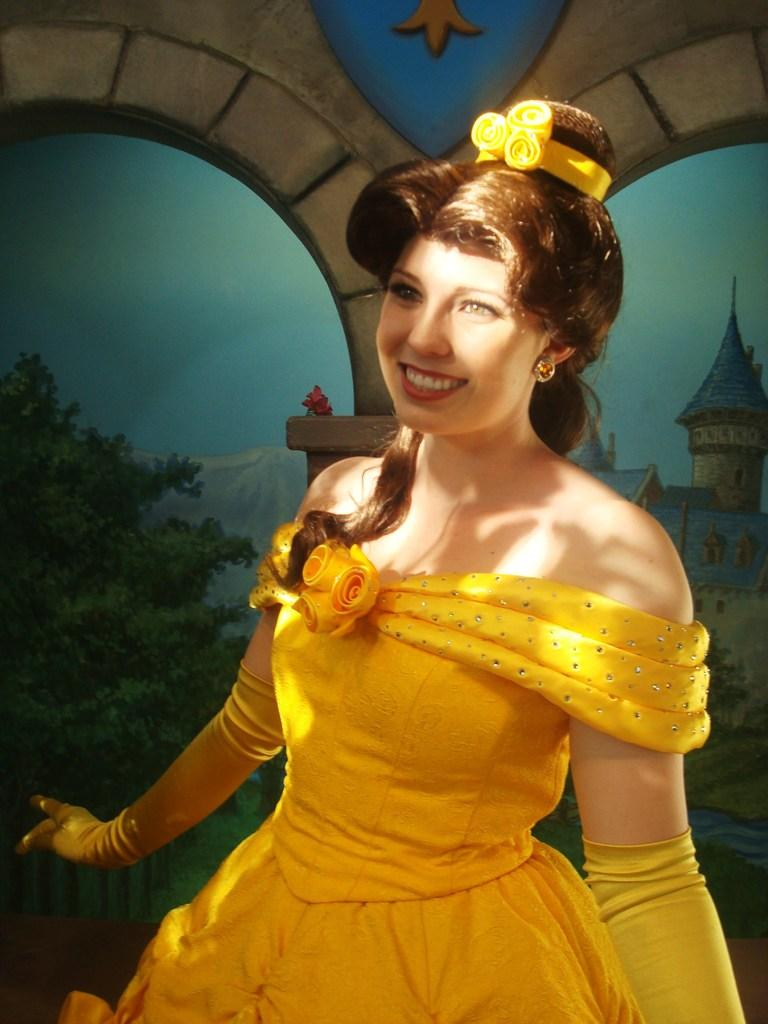Who is present in the image? There is a woman in the image. What is the woman wearing? The woman is wearing a yellow dress. What can be seen behind the woman? There is a wall behind the woman. What type of crate is being used by the woman in the image? There is no crate present in the image; the woman is standing in front of a wall. 